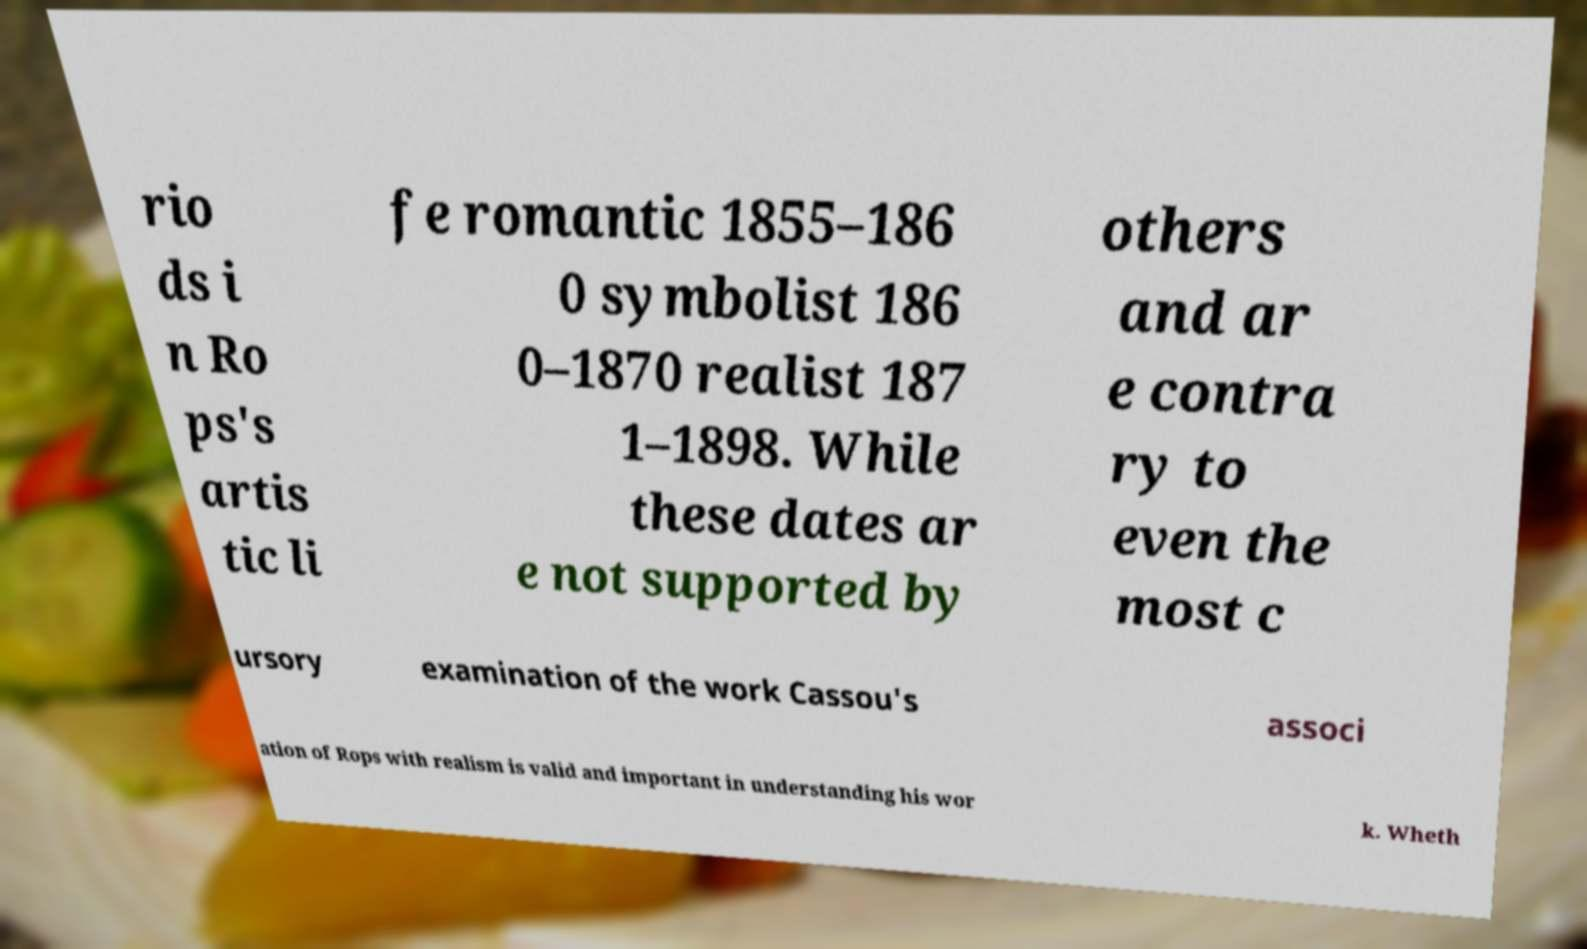Can you read and provide the text displayed in the image?This photo seems to have some interesting text. Can you extract and type it out for me? rio ds i n Ro ps's artis tic li fe romantic 1855–186 0 symbolist 186 0–1870 realist 187 1–1898. While these dates ar e not supported by others and ar e contra ry to even the most c ursory examination of the work Cassou's associ ation of Rops with realism is valid and important in understanding his wor k. Wheth 